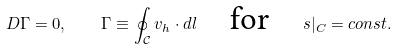Convert formula to latex. <formula><loc_0><loc_0><loc_500><loc_500>D \Gamma = 0 , \quad \Gamma \equiv \oint _ { \mathcal { C } } v _ { h } \cdot d l \quad \text {for} \quad s | _ { C } = c o n s t .</formula> 